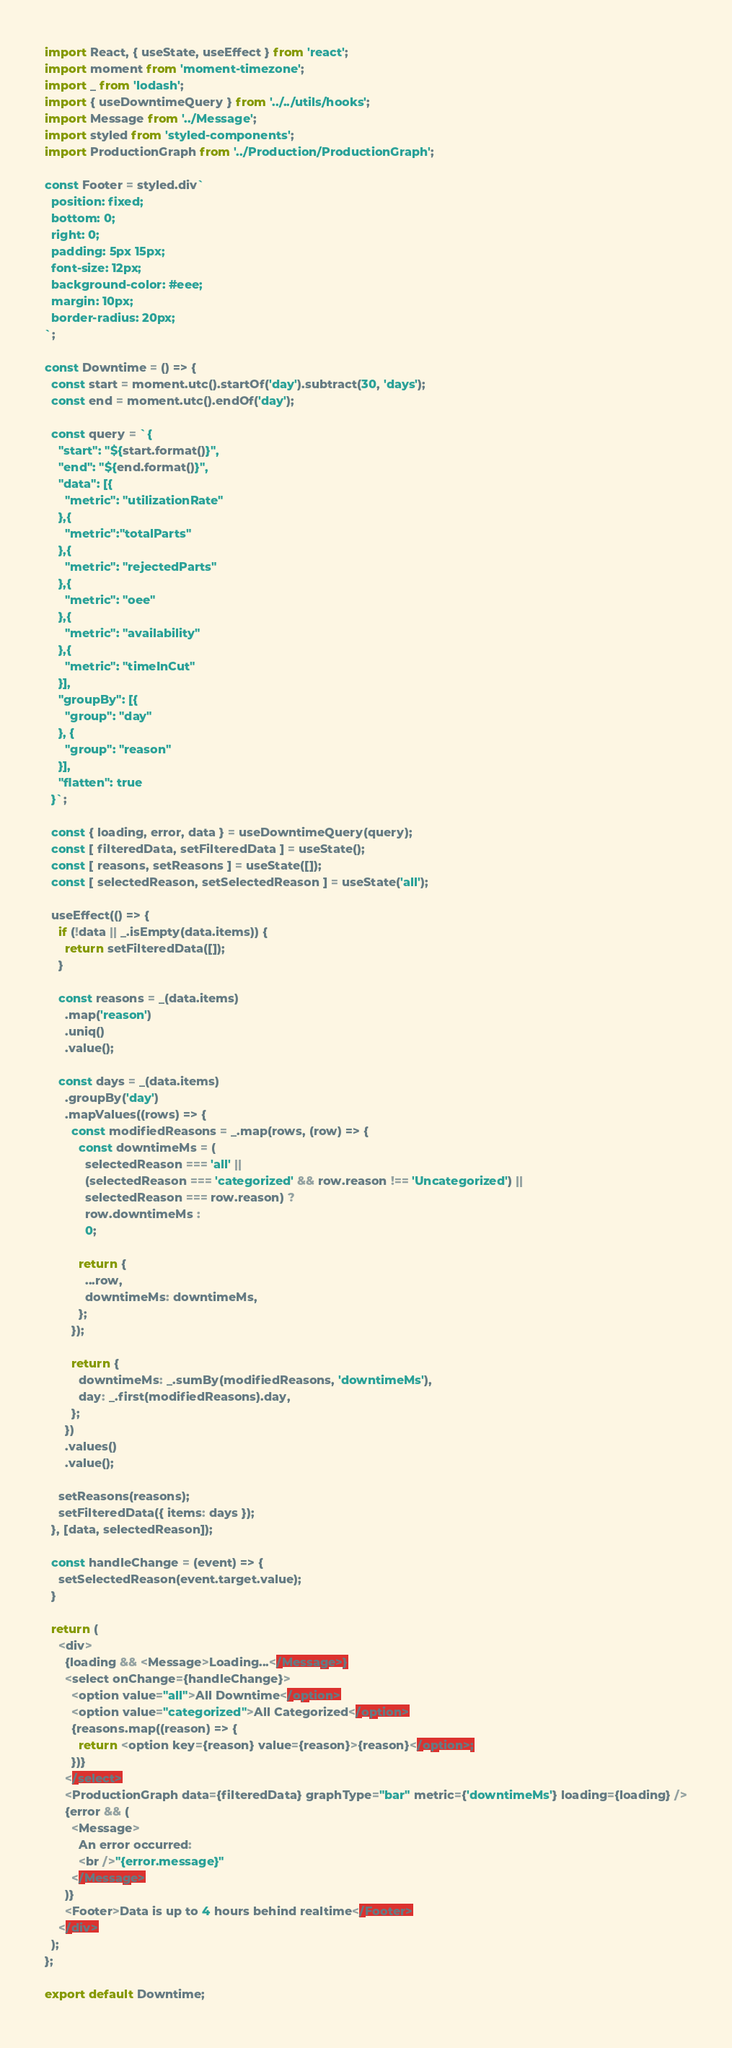<code> <loc_0><loc_0><loc_500><loc_500><_JavaScript_>import React, { useState, useEffect } from 'react';
import moment from 'moment-timezone';
import _ from 'lodash';
import { useDowntimeQuery } from '../../utils/hooks';
import Message from '../Message';
import styled from 'styled-components';
import ProductionGraph from '../Production/ProductionGraph';

const Footer = styled.div`
  position: fixed;
  bottom: 0;
  right: 0;
  padding: 5px 15px;
  font-size: 12px;
  background-color: #eee;
  margin: 10px;
  border-radius: 20px;
`;

const Downtime = () => {
  const start = moment.utc().startOf('day').subtract(30, 'days');
  const end = moment.utc().endOf('day');

  const query = `{
    "start": "${start.format()}",
    "end": "${end.format()}",
    "data": [{
      "metric": "utilizationRate"
    },{
      "metric":"totalParts"
    },{
      "metric": "rejectedParts"
    },{
      "metric": "oee"
    },{
      "metric": "availability"
    },{
      "metric": "timeInCut"
    }],
    "groupBy": [{
      "group": "day"
    }, {
      "group": "reason"
    }],
    "flatten": true
  }`;

  const { loading, error, data } = useDowntimeQuery(query);
  const [ filteredData, setFilteredData ] = useState();
  const [ reasons, setReasons ] = useState([]);
  const [ selectedReason, setSelectedReason ] = useState('all');

  useEffect(() => {
    if (!data || _.isEmpty(data.items)) {
      return setFilteredData([]);
    }

    const reasons = _(data.items)
      .map('reason')
      .uniq()
      .value();

    const days = _(data.items)
      .groupBy('day')
      .mapValues((rows) => {
        const modifiedReasons = _.map(rows, (row) => {
          const downtimeMs = (
            selectedReason === 'all' ||
            (selectedReason === 'categorized' && row.reason !== 'Uncategorized') ||
            selectedReason === row.reason) ?
            row.downtimeMs :
            0;

          return {
            ...row,
            downtimeMs: downtimeMs,
          };
        });

        return {
          downtimeMs: _.sumBy(modifiedReasons, 'downtimeMs'),
          day: _.first(modifiedReasons).day,
        };
      })
      .values()
      .value();

    setReasons(reasons);
    setFilteredData({ items: days });
  }, [data, selectedReason]);

  const handleChange = (event) => {
    setSelectedReason(event.target.value);
  }

  return (
    <div>
      {loading && <Message>Loading...</Message>}
      <select onChange={handleChange}>
        <option value="all">All Downtime</option>
        <option value="categorized">All Categorized</option>
        {reasons.map((reason) => {
          return <option key={reason} value={reason}>{reason}</option>;
        })}
      </select>
      <ProductionGraph data={filteredData} graphType="bar" metric={'downtimeMs'} loading={loading} />
      {error && (
        <Message>
          An error occurred:
          <br />"{error.message}"
        </Message>
      )}
      <Footer>Data is up to 4 hours behind realtime</Footer>
    </div>
  );
};

export default Downtime;
</code> 